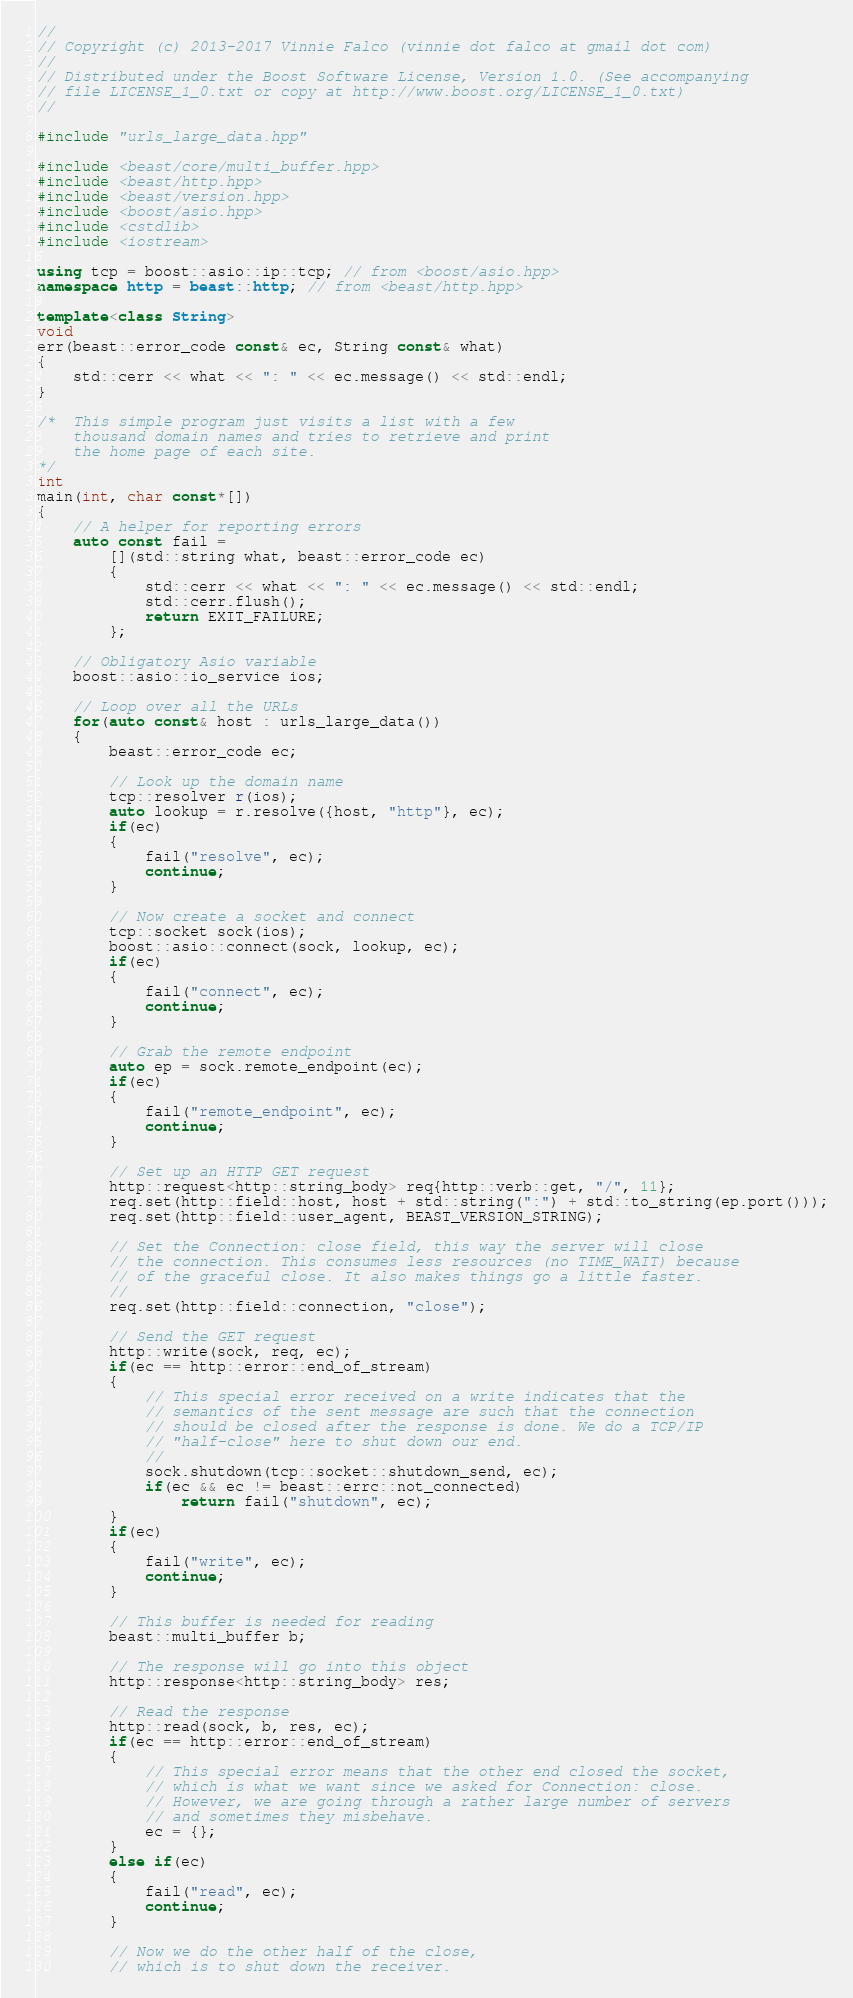<code> <loc_0><loc_0><loc_500><loc_500><_C++_>//
// Copyright (c) 2013-2017 Vinnie Falco (vinnie dot falco at gmail dot com)
//
// Distributed under the Boost Software License, Version 1.0. (See accompanying
// file LICENSE_1_0.txt or copy at http://www.boost.org/LICENSE_1_0.txt)
//

#include "urls_large_data.hpp"

#include <beast/core/multi_buffer.hpp>
#include <beast/http.hpp>
#include <beast/version.hpp>
#include <boost/asio.hpp>
#include <cstdlib>
#include <iostream>

using tcp = boost::asio::ip::tcp; // from <boost/asio.hpp>
namespace http = beast::http; // from <beast/http.hpp>

template<class String>
void
err(beast::error_code const& ec, String const& what)
{
    std::cerr << what << ": " << ec.message() << std::endl;
}

/*  This simple program just visits a list with a few
    thousand domain names and tries to retrieve and print
    the home page of each site.
*/
int
main(int, char const*[])
{
    // A helper for reporting errors
    auto const fail =
        [](std::string what, beast::error_code ec)
        {
            std::cerr << what << ": " << ec.message() << std::endl;
            std::cerr.flush();
            return EXIT_FAILURE;
        };

    // Obligatory Asio variable
    boost::asio::io_service ios;

    // Loop over all the URLs
    for(auto const& host : urls_large_data())
    {
        beast::error_code ec;

        // Look up the domain name
        tcp::resolver r(ios);
        auto lookup = r.resolve({host, "http"}, ec);
        if(ec)
        {
            fail("resolve", ec);
            continue;
        }

        // Now create a socket and connect
        tcp::socket sock(ios);
        boost::asio::connect(sock, lookup, ec);
        if(ec)
        {
            fail("connect", ec);
            continue;
        }

        // Grab the remote endpoint
        auto ep = sock.remote_endpoint(ec);
        if(ec)
        {
            fail("remote_endpoint", ec);
            continue;
        }

        // Set up an HTTP GET request
        http::request<http::string_body> req{http::verb::get, "/", 11};
        req.set(http::field::host, host + std::string(":") + std::to_string(ep.port()));
        req.set(http::field::user_agent, BEAST_VERSION_STRING);

        // Set the Connection: close field, this way the server will close
        // the connection. This consumes less resources (no TIME_WAIT) because
        // of the graceful close. It also makes things go a little faster.
        //
        req.set(http::field::connection, "close");

        // Send the GET request
        http::write(sock, req, ec);
        if(ec == http::error::end_of_stream)
        {
            // This special error received on a write indicates that the
            // semantics of the sent message are such that the connection
            // should be closed after the response is done. We do a TCP/IP
            // "half-close" here to shut down our end.
            //
            sock.shutdown(tcp::socket::shutdown_send, ec);
            if(ec && ec != beast::errc::not_connected)
                return fail("shutdown", ec);
        }
        if(ec)
        {
            fail("write", ec);
            continue;
        }

        // This buffer is needed for reading
        beast::multi_buffer b;

        // The response will go into this object
        http::response<http::string_body> res;

        // Read the response
        http::read(sock, b, res, ec);
        if(ec == http::error::end_of_stream)
        {
            // This special error means that the other end closed the socket,
            // which is what we want since we asked for Connection: close.
            // However, we are going through a rather large number of servers
            // and sometimes they misbehave.
            ec = {};
        }
        else if(ec)
        {
            fail("read", ec);
            continue;
        }

        // Now we do the other half of the close,
        // which is to shut down the receiver. </code> 